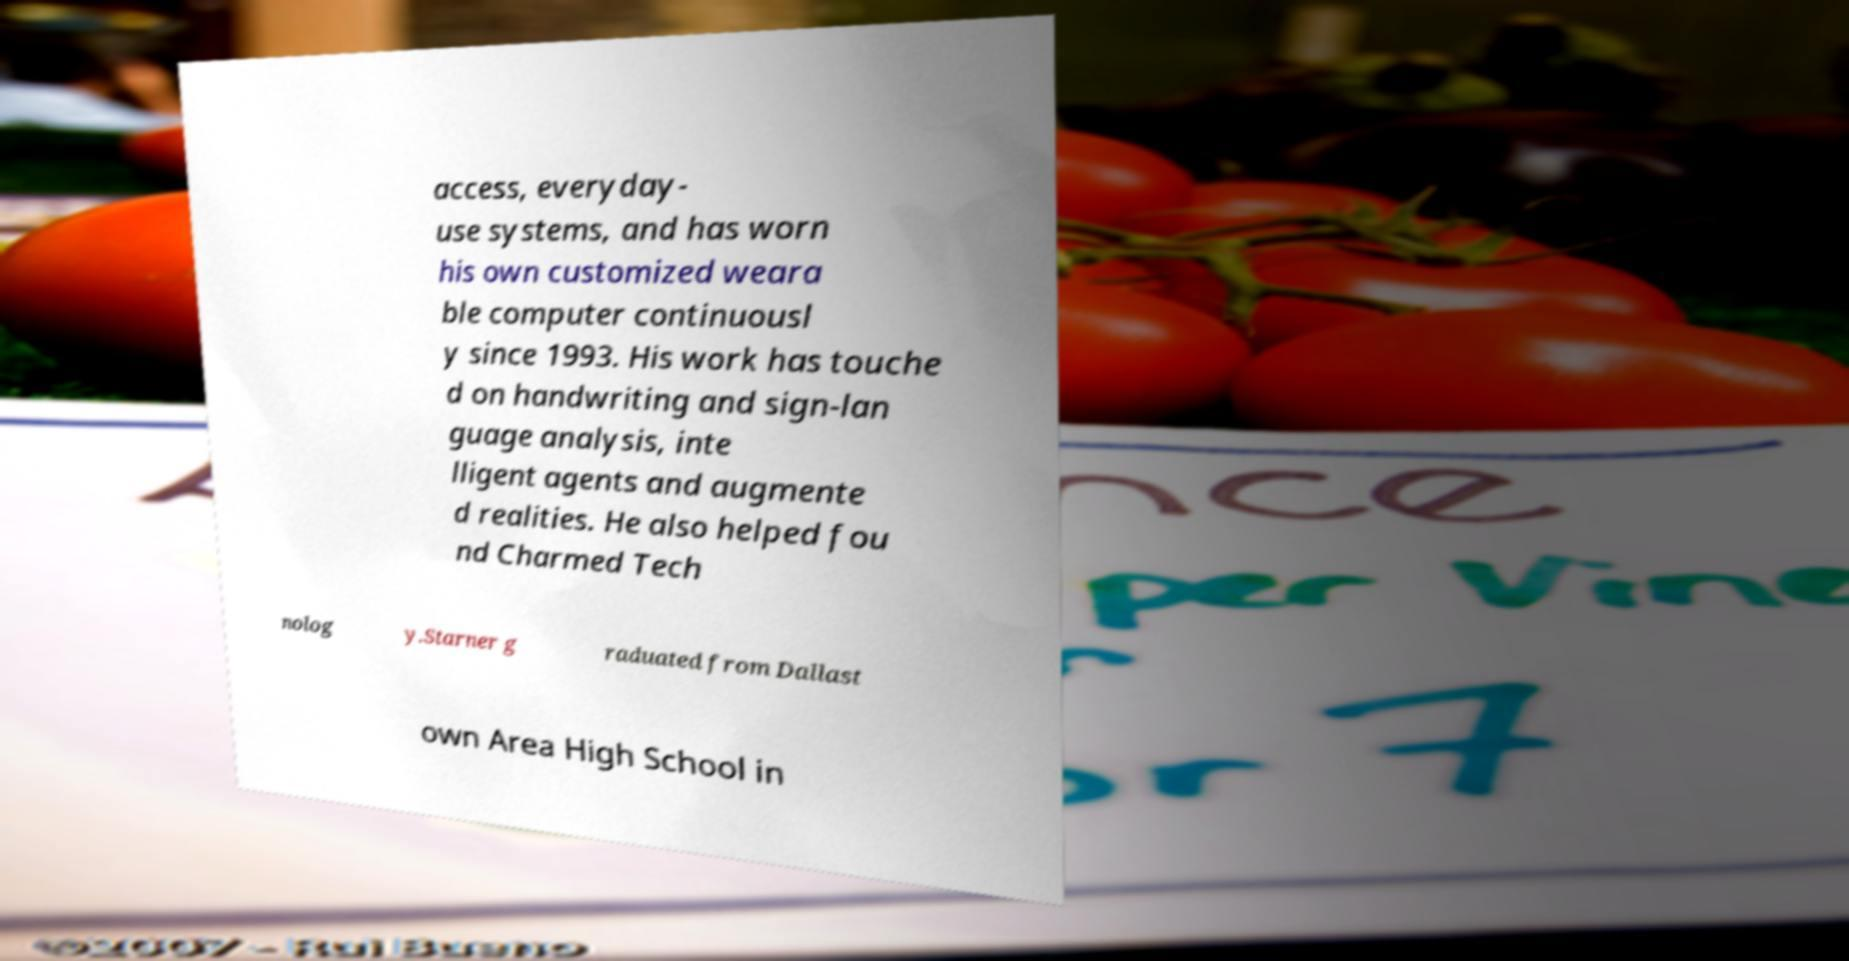Can you read and provide the text displayed in the image?This photo seems to have some interesting text. Can you extract and type it out for me? access, everyday- use systems, and has worn his own customized weara ble computer continuousl y since 1993. His work has touche d on handwriting and sign-lan guage analysis, inte lligent agents and augmente d realities. He also helped fou nd Charmed Tech nolog y.Starner g raduated from Dallast own Area High School in 